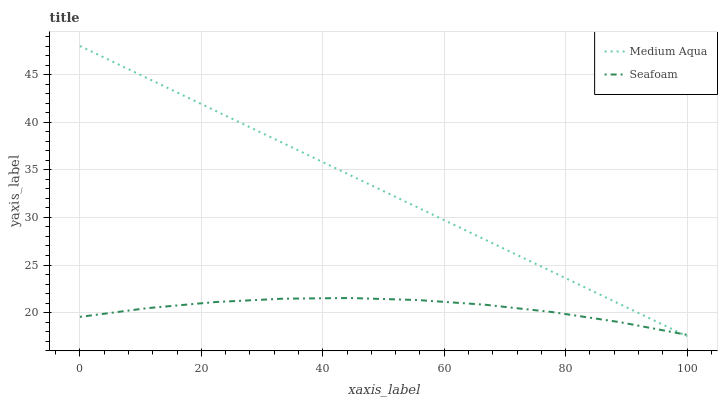Does Seafoam have the minimum area under the curve?
Answer yes or no. Yes. Does Medium Aqua have the maximum area under the curve?
Answer yes or no. Yes. Does Seafoam have the maximum area under the curve?
Answer yes or no. No. Is Medium Aqua the smoothest?
Answer yes or no. Yes. Is Seafoam the roughest?
Answer yes or no. Yes. Is Seafoam the smoothest?
Answer yes or no. No. Does Medium Aqua have the lowest value?
Answer yes or no. Yes. Does Seafoam have the lowest value?
Answer yes or no. No. Does Medium Aqua have the highest value?
Answer yes or no. Yes. Does Seafoam have the highest value?
Answer yes or no. No. Does Medium Aqua intersect Seafoam?
Answer yes or no. Yes. Is Medium Aqua less than Seafoam?
Answer yes or no. No. Is Medium Aqua greater than Seafoam?
Answer yes or no. No. 